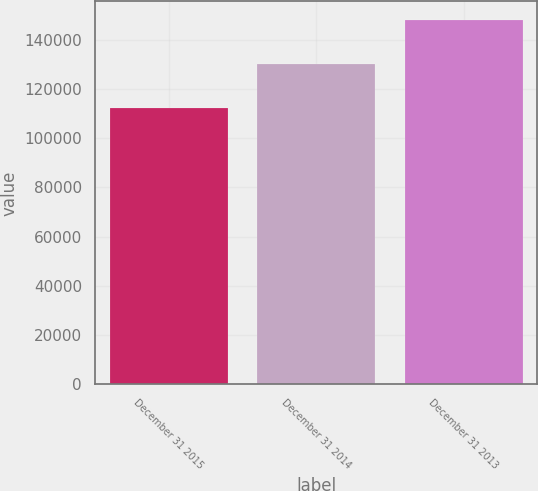Convert chart to OTSL. <chart><loc_0><loc_0><loc_500><loc_500><bar_chart><fcel>December 31 2015<fcel>December 31 2014<fcel>December 31 2013<nl><fcel>112376<fcel>130206<fcel>148161<nl></chart> 